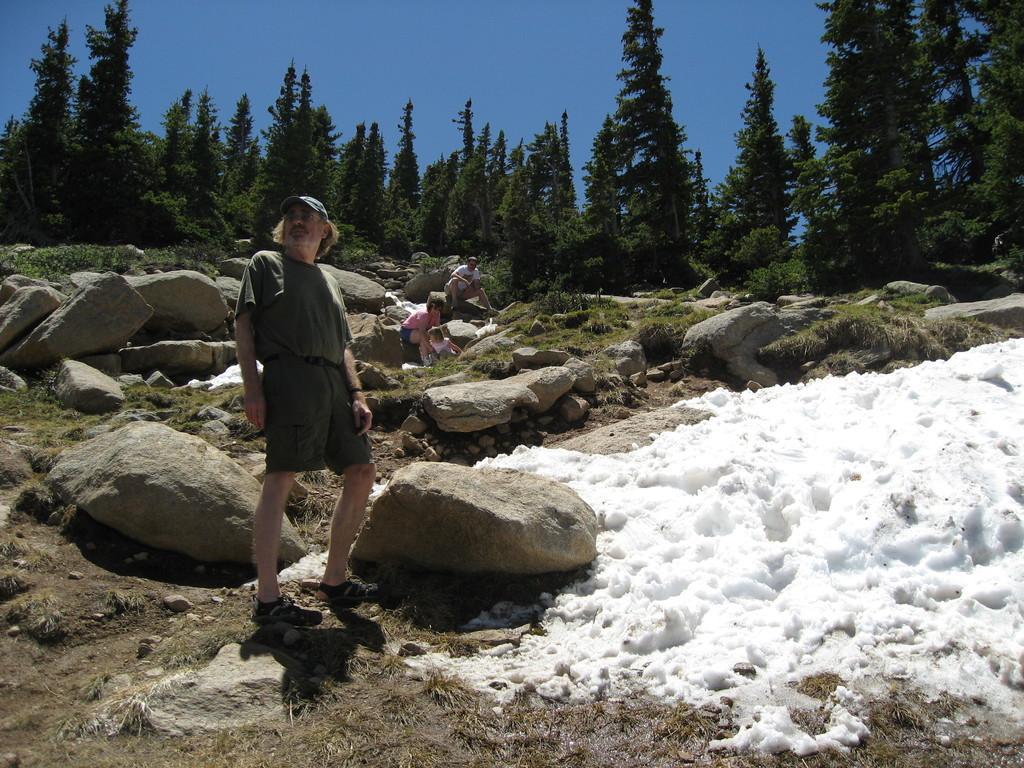How would you summarize this image in a sentence or two? There is a person standing in the image wearing a cap. In the background of the image there are trees. There are people sitting on rocks. To the right side of the image there is snow. At the bottom of the image there is grass. 